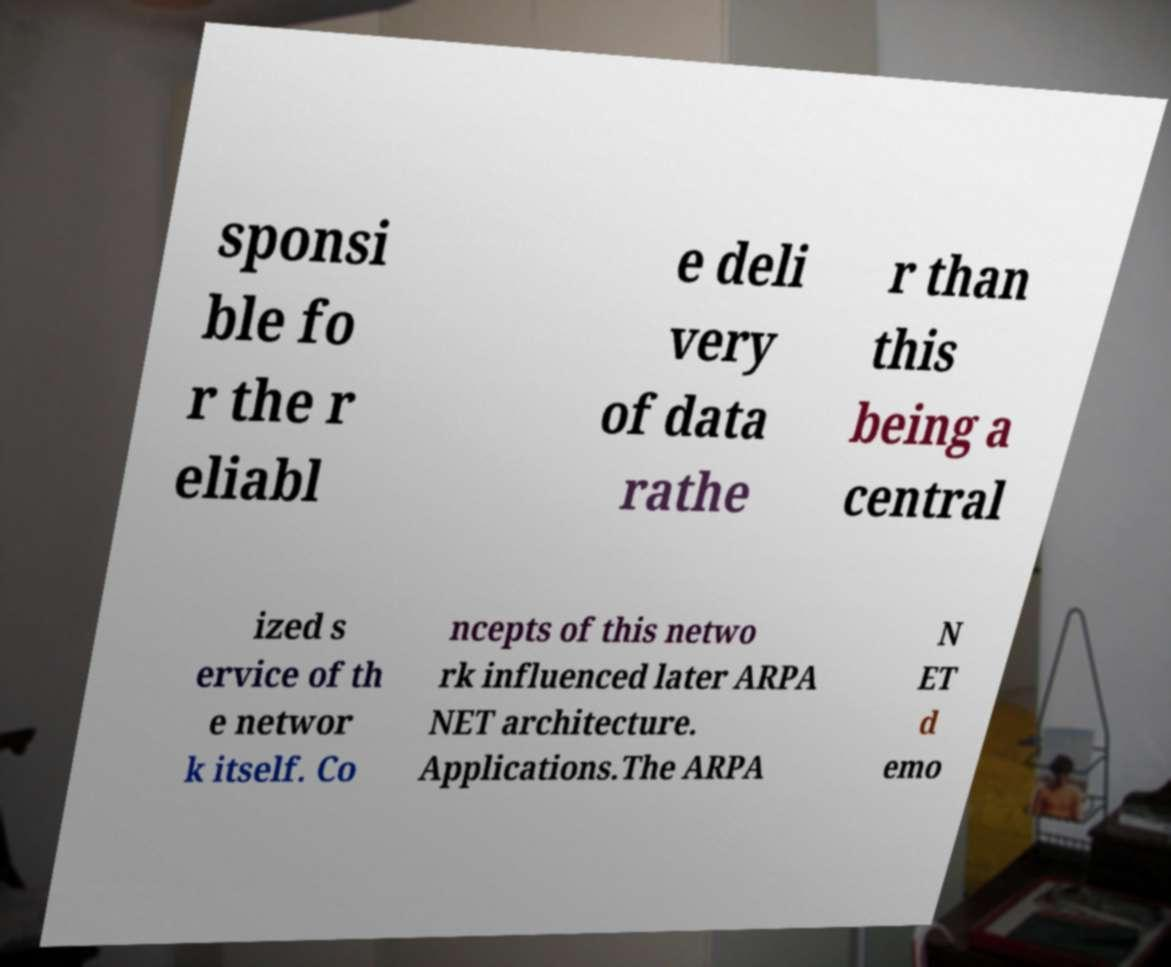What messages or text are displayed in this image? I need them in a readable, typed format. sponsi ble fo r the r eliabl e deli very of data rathe r than this being a central ized s ervice of th e networ k itself. Co ncepts of this netwo rk influenced later ARPA NET architecture. Applications.The ARPA N ET d emo 